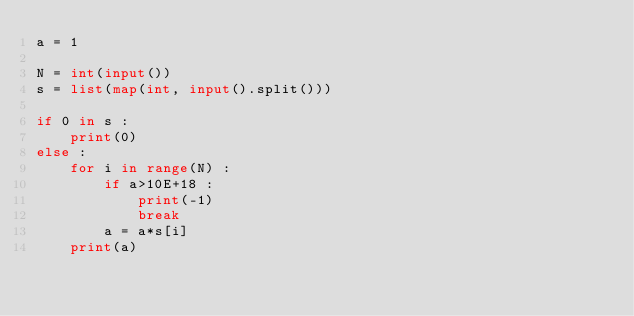<code> <loc_0><loc_0><loc_500><loc_500><_Python_>a = 1

N = int(input())
s = list(map(int, input().split()))

if 0 in s :
    print(0)
else :
    for i in range(N) :
        if a>10E+18 :
            print(-1)
            break
        a = a*s[i]
    print(a)</code> 